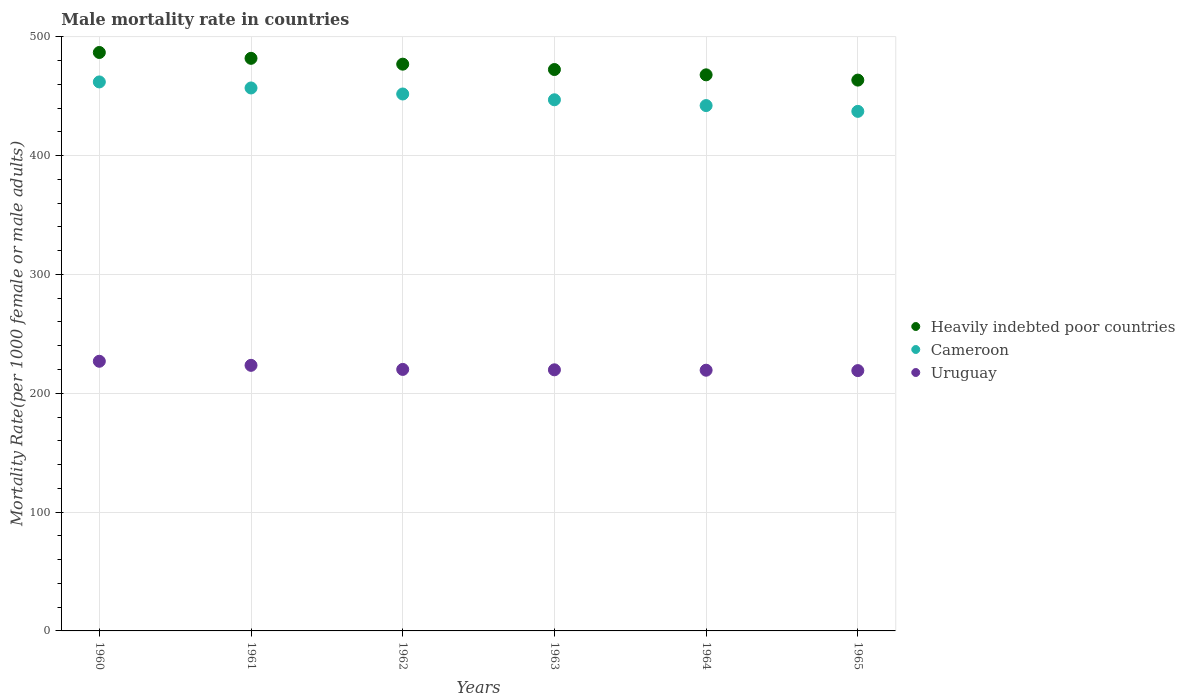How many different coloured dotlines are there?
Provide a short and direct response. 3. What is the male mortality rate in Uruguay in 1965?
Give a very brief answer. 219.07. Across all years, what is the maximum male mortality rate in Uruguay?
Your response must be concise. 226.93. Across all years, what is the minimum male mortality rate in Cameroon?
Your answer should be very brief. 437.24. In which year was the male mortality rate in Cameroon minimum?
Offer a very short reply. 1965. What is the total male mortality rate in Uruguay in the graph?
Offer a terse response. 1328.72. What is the difference between the male mortality rate in Uruguay in 1963 and that in 1965?
Keep it short and to the point. 0.67. What is the difference between the male mortality rate in Heavily indebted poor countries in 1960 and the male mortality rate in Cameroon in 1962?
Keep it short and to the point. 34.94. What is the average male mortality rate in Heavily indebted poor countries per year?
Make the answer very short. 474.93. In the year 1964, what is the difference between the male mortality rate in Uruguay and male mortality rate in Cameroon?
Keep it short and to the point. -222.71. In how many years, is the male mortality rate in Cameroon greater than 320?
Provide a short and direct response. 6. What is the ratio of the male mortality rate in Heavily indebted poor countries in 1961 to that in 1962?
Ensure brevity in your answer.  1.01. Is the difference between the male mortality rate in Uruguay in 1962 and 1963 greater than the difference between the male mortality rate in Cameroon in 1962 and 1963?
Provide a short and direct response. No. What is the difference between the highest and the second highest male mortality rate in Uruguay?
Provide a succinct answer. 3.43. What is the difference between the highest and the lowest male mortality rate in Cameroon?
Your answer should be compact. 24.77. In how many years, is the male mortality rate in Cameroon greater than the average male mortality rate in Cameroon taken over all years?
Provide a succinct answer. 3. Is it the case that in every year, the sum of the male mortality rate in Cameroon and male mortality rate in Heavily indebted poor countries  is greater than the male mortality rate in Uruguay?
Provide a short and direct response. Yes. Does the male mortality rate in Cameroon monotonically increase over the years?
Make the answer very short. No. What is the difference between two consecutive major ticks on the Y-axis?
Provide a short and direct response. 100. Are the values on the major ticks of Y-axis written in scientific E-notation?
Provide a short and direct response. No. Does the graph contain grids?
Provide a succinct answer. Yes. Where does the legend appear in the graph?
Provide a short and direct response. Center right. What is the title of the graph?
Provide a short and direct response. Male mortality rate in countries. Does "Luxembourg" appear as one of the legend labels in the graph?
Offer a very short reply. No. What is the label or title of the Y-axis?
Your response must be concise. Mortality Rate(per 1000 female or male adults). What is the Mortality Rate(per 1000 female or male adults) in Heavily indebted poor countries in 1960?
Provide a succinct answer. 486.79. What is the Mortality Rate(per 1000 female or male adults) of Cameroon in 1960?
Your answer should be very brief. 462.01. What is the Mortality Rate(per 1000 female or male adults) in Uruguay in 1960?
Your answer should be compact. 226.93. What is the Mortality Rate(per 1000 female or male adults) of Heavily indebted poor countries in 1961?
Provide a succinct answer. 481.87. What is the Mortality Rate(per 1000 female or male adults) of Cameroon in 1961?
Your answer should be compact. 456.93. What is the Mortality Rate(per 1000 female or male adults) of Uruguay in 1961?
Keep it short and to the point. 223.5. What is the Mortality Rate(per 1000 female or male adults) in Heavily indebted poor countries in 1962?
Provide a short and direct response. 476.96. What is the Mortality Rate(per 1000 female or male adults) of Cameroon in 1962?
Give a very brief answer. 451.86. What is the Mortality Rate(per 1000 female or male adults) of Uruguay in 1962?
Your answer should be compact. 220.07. What is the Mortality Rate(per 1000 female or male adults) of Heavily indebted poor countries in 1963?
Give a very brief answer. 472.45. What is the Mortality Rate(per 1000 female or male adults) in Cameroon in 1963?
Your response must be concise. 446.98. What is the Mortality Rate(per 1000 female or male adults) of Uruguay in 1963?
Offer a terse response. 219.74. What is the Mortality Rate(per 1000 female or male adults) in Heavily indebted poor countries in 1964?
Offer a very short reply. 467.98. What is the Mortality Rate(per 1000 female or male adults) in Cameroon in 1964?
Your response must be concise. 442.11. What is the Mortality Rate(per 1000 female or male adults) of Uruguay in 1964?
Make the answer very short. 219.4. What is the Mortality Rate(per 1000 female or male adults) in Heavily indebted poor countries in 1965?
Make the answer very short. 463.55. What is the Mortality Rate(per 1000 female or male adults) of Cameroon in 1965?
Your response must be concise. 437.24. What is the Mortality Rate(per 1000 female or male adults) of Uruguay in 1965?
Offer a terse response. 219.07. Across all years, what is the maximum Mortality Rate(per 1000 female or male adults) in Heavily indebted poor countries?
Offer a very short reply. 486.79. Across all years, what is the maximum Mortality Rate(per 1000 female or male adults) in Cameroon?
Your answer should be very brief. 462.01. Across all years, what is the maximum Mortality Rate(per 1000 female or male adults) of Uruguay?
Give a very brief answer. 226.93. Across all years, what is the minimum Mortality Rate(per 1000 female or male adults) of Heavily indebted poor countries?
Offer a terse response. 463.55. Across all years, what is the minimum Mortality Rate(per 1000 female or male adults) in Cameroon?
Your answer should be very brief. 437.24. Across all years, what is the minimum Mortality Rate(per 1000 female or male adults) of Uruguay?
Ensure brevity in your answer.  219.07. What is the total Mortality Rate(per 1000 female or male adults) of Heavily indebted poor countries in the graph?
Offer a very short reply. 2849.6. What is the total Mortality Rate(per 1000 female or male adults) in Cameroon in the graph?
Offer a very short reply. 2697.13. What is the total Mortality Rate(per 1000 female or male adults) of Uruguay in the graph?
Your answer should be very brief. 1328.72. What is the difference between the Mortality Rate(per 1000 female or male adults) of Heavily indebted poor countries in 1960 and that in 1961?
Your answer should be very brief. 4.92. What is the difference between the Mortality Rate(per 1000 female or male adults) of Cameroon in 1960 and that in 1961?
Offer a terse response. 5.08. What is the difference between the Mortality Rate(per 1000 female or male adults) of Uruguay in 1960 and that in 1961?
Make the answer very short. 3.43. What is the difference between the Mortality Rate(per 1000 female or male adults) in Heavily indebted poor countries in 1960 and that in 1962?
Give a very brief answer. 9.83. What is the difference between the Mortality Rate(per 1000 female or male adults) in Cameroon in 1960 and that in 1962?
Offer a terse response. 10.15. What is the difference between the Mortality Rate(per 1000 female or male adults) of Uruguay in 1960 and that in 1962?
Make the answer very short. 6.86. What is the difference between the Mortality Rate(per 1000 female or male adults) of Heavily indebted poor countries in 1960 and that in 1963?
Ensure brevity in your answer.  14.34. What is the difference between the Mortality Rate(per 1000 female or male adults) in Cameroon in 1960 and that in 1963?
Your answer should be compact. 15.02. What is the difference between the Mortality Rate(per 1000 female or male adults) of Uruguay in 1960 and that in 1963?
Offer a terse response. 7.2. What is the difference between the Mortality Rate(per 1000 female or male adults) of Heavily indebted poor countries in 1960 and that in 1964?
Offer a very short reply. 18.81. What is the difference between the Mortality Rate(per 1000 female or male adults) in Cameroon in 1960 and that in 1964?
Make the answer very short. 19.89. What is the difference between the Mortality Rate(per 1000 female or male adults) in Uruguay in 1960 and that in 1964?
Your answer should be very brief. 7.53. What is the difference between the Mortality Rate(per 1000 female or male adults) of Heavily indebted poor countries in 1960 and that in 1965?
Give a very brief answer. 23.24. What is the difference between the Mortality Rate(per 1000 female or male adults) of Cameroon in 1960 and that in 1965?
Give a very brief answer. 24.77. What is the difference between the Mortality Rate(per 1000 female or male adults) in Uruguay in 1960 and that in 1965?
Give a very brief answer. 7.86. What is the difference between the Mortality Rate(per 1000 female or male adults) of Heavily indebted poor countries in 1961 and that in 1962?
Keep it short and to the point. 4.91. What is the difference between the Mortality Rate(per 1000 female or male adults) in Cameroon in 1961 and that in 1962?
Your response must be concise. 5.08. What is the difference between the Mortality Rate(per 1000 female or male adults) in Uruguay in 1961 and that in 1962?
Offer a very short reply. 3.43. What is the difference between the Mortality Rate(per 1000 female or male adults) of Heavily indebted poor countries in 1961 and that in 1963?
Offer a terse response. 9.42. What is the difference between the Mortality Rate(per 1000 female or male adults) of Cameroon in 1961 and that in 1963?
Your answer should be very brief. 9.95. What is the difference between the Mortality Rate(per 1000 female or male adults) in Uruguay in 1961 and that in 1963?
Your answer should be compact. 3.77. What is the difference between the Mortality Rate(per 1000 female or male adults) of Heavily indebted poor countries in 1961 and that in 1964?
Give a very brief answer. 13.89. What is the difference between the Mortality Rate(per 1000 female or male adults) in Cameroon in 1961 and that in 1964?
Your answer should be very brief. 14.82. What is the difference between the Mortality Rate(per 1000 female or male adults) of Uruguay in 1961 and that in 1964?
Offer a terse response. 4.1. What is the difference between the Mortality Rate(per 1000 female or male adults) of Heavily indebted poor countries in 1961 and that in 1965?
Offer a terse response. 18.32. What is the difference between the Mortality Rate(per 1000 female or male adults) of Cameroon in 1961 and that in 1965?
Make the answer very short. 19.69. What is the difference between the Mortality Rate(per 1000 female or male adults) in Uruguay in 1961 and that in 1965?
Give a very brief answer. 4.43. What is the difference between the Mortality Rate(per 1000 female or male adults) of Heavily indebted poor countries in 1962 and that in 1963?
Your response must be concise. 4.51. What is the difference between the Mortality Rate(per 1000 female or male adults) in Cameroon in 1962 and that in 1963?
Offer a terse response. 4.87. What is the difference between the Mortality Rate(per 1000 female or male adults) in Uruguay in 1962 and that in 1963?
Offer a very short reply. 0.33. What is the difference between the Mortality Rate(per 1000 female or male adults) of Heavily indebted poor countries in 1962 and that in 1964?
Offer a very short reply. 8.98. What is the difference between the Mortality Rate(per 1000 female or male adults) in Cameroon in 1962 and that in 1964?
Your answer should be compact. 9.74. What is the difference between the Mortality Rate(per 1000 female or male adults) in Uruguay in 1962 and that in 1964?
Make the answer very short. 0.67. What is the difference between the Mortality Rate(per 1000 female or male adults) of Heavily indebted poor countries in 1962 and that in 1965?
Offer a very short reply. 13.41. What is the difference between the Mortality Rate(per 1000 female or male adults) in Cameroon in 1962 and that in 1965?
Make the answer very short. 14.61. What is the difference between the Mortality Rate(per 1000 female or male adults) in Heavily indebted poor countries in 1963 and that in 1964?
Your answer should be very brief. 4.47. What is the difference between the Mortality Rate(per 1000 female or male adults) in Cameroon in 1963 and that in 1964?
Offer a very short reply. 4.87. What is the difference between the Mortality Rate(per 1000 female or male adults) of Uruguay in 1963 and that in 1964?
Provide a succinct answer. 0.33. What is the difference between the Mortality Rate(per 1000 female or male adults) of Heavily indebted poor countries in 1963 and that in 1965?
Offer a terse response. 8.9. What is the difference between the Mortality Rate(per 1000 female or male adults) of Cameroon in 1963 and that in 1965?
Keep it short and to the point. 9.74. What is the difference between the Mortality Rate(per 1000 female or male adults) of Uruguay in 1963 and that in 1965?
Provide a short and direct response. 0.67. What is the difference between the Mortality Rate(per 1000 female or male adults) of Heavily indebted poor countries in 1964 and that in 1965?
Offer a terse response. 4.43. What is the difference between the Mortality Rate(per 1000 female or male adults) in Cameroon in 1964 and that in 1965?
Provide a succinct answer. 4.87. What is the difference between the Mortality Rate(per 1000 female or male adults) of Uruguay in 1964 and that in 1965?
Offer a very short reply. 0.33. What is the difference between the Mortality Rate(per 1000 female or male adults) in Heavily indebted poor countries in 1960 and the Mortality Rate(per 1000 female or male adults) in Cameroon in 1961?
Your answer should be very brief. 29.86. What is the difference between the Mortality Rate(per 1000 female or male adults) of Heavily indebted poor countries in 1960 and the Mortality Rate(per 1000 female or male adults) of Uruguay in 1961?
Provide a short and direct response. 263.29. What is the difference between the Mortality Rate(per 1000 female or male adults) of Cameroon in 1960 and the Mortality Rate(per 1000 female or male adults) of Uruguay in 1961?
Your response must be concise. 238.5. What is the difference between the Mortality Rate(per 1000 female or male adults) of Heavily indebted poor countries in 1960 and the Mortality Rate(per 1000 female or male adults) of Cameroon in 1962?
Provide a short and direct response. 34.94. What is the difference between the Mortality Rate(per 1000 female or male adults) in Heavily indebted poor countries in 1960 and the Mortality Rate(per 1000 female or male adults) in Uruguay in 1962?
Offer a terse response. 266.72. What is the difference between the Mortality Rate(per 1000 female or male adults) of Cameroon in 1960 and the Mortality Rate(per 1000 female or male adults) of Uruguay in 1962?
Make the answer very short. 241.94. What is the difference between the Mortality Rate(per 1000 female or male adults) of Heavily indebted poor countries in 1960 and the Mortality Rate(per 1000 female or male adults) of Cameroon in 1963?
Provide a succinct answer. 39.81. What is the difference between the Mortality Rate(per 1000 female or male adults) of Heavily indebted poor countries in 1960 and the Mortality Rate(per 1000 female or male adults) of Uruguay in 1963?
Your answer should be very brief. 267.06. What is the difference between the Mortality Rate(per 1000 female or male adults) in Cameroon in 1960 and the Mortality Rate(per 1000 female or male adults) in Uruguay in 1963?
Your answer should be compact. 242.27. What is the difference between the Mortality Rate(per 1000 female or male adults) of Heavily indebted poor countries in 1960 and the Mortality Rate(per 1000 female or male adults) of Cameroon in 1964?
Make the answer very short. 44.68. What is the difference between the Mortality Rate(per 1000 female or male adults) in Heavily indebted poor countries in 1960 and the Mortality Rate(per 1000 female or male adults) in Uruguay in 1964?
Offer a very short reply. 267.39. What is the difference between the Mortality Rate(per 1000 female or male adults) in Cameroon in 1960 and the Mortality Rate(per 1000 female or male adults) in Uruguay in 1964?
Keep it short and to the point. 242.6. What is the difference between the Mortality Rate(per 1000 female or male adults) in Heavily indebted poor countries in 1960 and the Mortality Rate(per 1000 female or male adults) in Cameroon in 1965?
Provide a short and direct response. 49.55. What is the difference between the Mortality Rate(per 1000 female or male adults) in Heavily indebted poor countries in 1960 and the Mortality Rate(per 1000 female or male adults) in Uruguay in 1965?
Ensure brevity in your answer.  267.72. What is the difference between the Mortality Rate(per 1000 female or male adults) of Cameroon in 1960 and the Mortality Rate(per 1000 female or male adults) of Uruguay in 1965?
Your response must be concise. 242.94. What is the difference between the Mortality Rate(per 1000 female or male adults) of Heavily indebted poor countries in 1961 and the Mortality Rate(per 1000 female or male adults) of Cameroon in 1962?
Your answer should be compact. 30.02. What is the difference between the Mortality Rate(per 1000 female or male adults) in Heavily indebted poor countries in 1961 and the Mortality Rate(per 1000 female or male adults) in Uruguay in 1962?
Keep it short and to the point. 261.8. What is the difference between the Mortality Rate(per 1000 female or male adults) in Cameroon in 1961 and the Mortality Rate(per 1000 female or male adults) in Uruguay in 1962?
Offer a terse response. 236.86. What is the difference between the Mortality Rate(per 1000 female or male adults) in Heavily indebted poor countries in 1961 and the Mortality Rate(per 1000 female or male adults) in Cameroon in 1963?
Your answer should be compact. 34.89. What is the difference between the Mortality Rate(per 1000 female or male adults) in Heavily indebted poor countries in 1961 and the Mortality Rate(per 1000 female or male adults) in Uruguay in 1963?
Ensure brevity in your answer.  262.13. What is the difference between the Mortality Rate(per 1000 female or male adults) of Cameroon in 1961 and the Mortality Rate(per 1000 female or male adults) of Uruguay in 1963?
Offer a very short reply. 237.19. What is the difference between the Mortality Rate(per 1000 female or male adults) in Heavily indebted poor countries in 1961 and the Mortality Rate(per 1000 female or male adults) in Cameroon in 1964?
Your answer should be compact. 39.76. What is the difference between the Mortality Rate(per 1000 female or male adults) of Heavily indebted poor countries in 1961 and the Mortality Rate(per 1000 female or male adults) of Uruguay in 1964?
Make the answer very short. 262.47. What is the difference between the Mortality Rate(per 1000 female or male adults) in Cameroon in 1961 and the Mortality Rate(per 1000 female or male adults) in Uruguay in 1964?
Make the answer very short. 237.53. What is the difference between the Mortality Rate(per 1000 female or male adults) in Heavily indebted poor countries in 1961 and the Mortality Rate(per 1000 female or male adults) in Cameroon in 1965?
Offer a terse response. 44.63. What is the difference between the Mortality Rate(per 1000 female or male adults) of Heavily indebted poor countries in 1961 and the Mortality Rate(per 1000 female or male adults) of Uruguay in 1965?
Ensure brevity in your answer.  262.8. What is the difference between the Mortality Rate(per 1000 female or male adults) of Cameroon in 1961 and the Mortality Rate(per 1000 female or male adults) of Uruguay in 1965?
Offer a very short reply. 237.86. What is the difference between the Mortality Rate(per 1000 female or male adults) in Heavily indebted poor countries in 1962 and the Mortality Rate(per 1000 female or male adults) in Cameroon in 1963?
Give a very brief answer. 29.97. What is the difference between the Mortality Rate(per 1000 female or male adults) in Heavily indebted poor countries in 1962 and the Mortality Rate(per 1000 female or male adults) in Uruguay in 1963?
Make the answer very short. 257.22. What is the difference between the Mortality Rate(per 1000 female or male adults) of Cameroon in 1962 and the Mortality Rate(per 1000 female or male adults) of Uruguay in 1963?
Provide a short and direct response. 232.12. What is the difference between the Mortality Rate(per 1000 female or male adults) of Heavily indebted poor countries in 1962 and the Mortality Rate(per 1000 female or male adults) of Cameroon in 1964?
Provide a succinct answer. 34.85. What is the difference between the Mortality Rate(per 1000 female or male adults) in Heavily indebted poor countries in 1962 and the Mortality Rate(per 1000 female or male adults) in Uruguay in 1964?
Provide a short and direct response. 257.55. What is the difference between the Mortality Rate(per 1000 female or male adults) of Cameroon in 1962 and the Mortality Rate(per 1000 female or male adults) of Uruguay in 1964?
Offer a terse response. 232.45. What is the difference between the Mortality Rate(per 1000 female or male adults) of Heavily indebted poor countries in 1962 and the Mortality Rate(per 1000 female or male adults) of Cameroon in 1965?
Your answer should be very brief. 39.72. What is the difference between the Mortality Rate(per 1000 female or male adults) of Heavily indebted poor countries in 1962 and the Mortality Rate(per 1000 female or male adults) of Uruguay in 1965?
Your answer should be very brief. 257.89. What is the difference between the Mortality Rate(per 1000 female or male adults) of Cameroon in 1962 and the Mortality Rate(per 1000 female or male adults) of Uruguay in 1965?
Your response must be concise. 232.78. What is the difference between the Mortality Rate(per 1000 female or male adults) in Heavily indebted poor countries in 1963 and the Mortality Rate(per 1000 female or male adults) in Cameroon in 1964?
Offer a very short reply. 30.34. What is the difference between the Mortality Rate(per 1000 female or male adults) in Heavily indebted poor countries in 1963 and the Mortality Rate(per 1000 female or male adults) in Uruguay in 1964?
Offer a very short reply. 253.05. What is the difference between the Mortality Rate(per 1000 female or male adults) in Cameroon in 1963 and the Mortality Rate(per 1000 female or male adults) in Uruguay in 1964?
Make the answer very short. 227.58. What is the difference between the Mortality Rate(per 1000 female or male adults) in Heavily indebted poor countries in 1963 and the Mortality Rate(per 1000 female or male adults) in Cameroon in 1965?
Make the answer very short. 35.21. What is the difference between the Mortality Rate(per 1000 female or male adults) in Heavily indebted poor countries in 1963 and the Mortality Rate(per 1000 female or male adults) in Uruguay in 1965?
Provide a short and direct response. 253.38. What is the difference between the Mortality Rate(per 1000 female or male adults) of Cameroon in 1963 and the Mortality Rate(per 1000 female or male adults) of Uruguay in 1965?
Make the answer very short. 227.91. What is the difference between the Mortality Rate(per 1000 female or male adults) in Heavily indebted poor countries in 1964 and the Mortality Rate(per 1000 female or male adults) in Cameroon in 1965?
Provide a succinct answer. 30.74. What is the difference between the Mortality Rate(per 1000 female or male adults) in Heavily indebted poor countries in 1964 and the Mortality Rate(per 1000 female or male adults) in Uruguay in 1965?
Make the answer very short. 248.91. What is the difference between the Mortality Rate(per 1000 female or male adults) of Cameroon in 1964 and the Mortality Rate(per 1000 female or male adults) of Uruguay in 1965?
Ensure brevity in your answer.  223.04. What is the average Mortality Rate(per 1000 female or male adults) of Heavily indebted poor countries per year?
Offer a very short reply. 474.93. What is the average Mortality Rate(per 1000 female or male adults) of Cameroon per year?
Ensure brevity in your answer.  449.52. What is the average Mortality Rate(per 1000 female or male adults) in Uruguay per year?
Your response must be concise. 221.45. In the year 1960, what is the difference between the Mortality Rate(per 1000 female or male adults) of Heavily indebted poor countries and Mortality Rate(per 1000 female or male adults) of Cameroon?
Keep it short and to the point. 24.79. In the year 1960, what is the difference between the Mortality Rate(per 1000 female or male adults) in Heavily indebted poor countries and Mortality Rate(per 1000 female or male adults) in Uruguay?
Give a very brief answer. 259.86. In the year 1960, what is the difference between the Mortality Rate(per 1000 female or male adults) in Cameroon and Mortality Rate(per 1000 female or male adults) in Uruguay?
Offer a terse response. 235.07. In the year 1961, what is the difference between the Mortality Rate(per 1000 female or male adults) of Heavily indebted poor countries and Mortality Rate(per 1000 female or male adults) of Cameroon?
Your answer should be compact. 24.94. In the year 1961, what is the difference between the Mortality Rate(per 1000 female or male adults) of Heavily indebted poor countries and Mortality Rate(per 1000 female or male adults) of Uruguay?
Make the answer very short. 258.37. In the year 1961, what is the difference between the Mortality Rate(per 1000 female or male adults) in Cameroon and Mortality Rate(per 1000 female or male adults) in Uruguay?
Give a very brief answer. 233.43. In the year 1962, what is the difference between the Mortality Rate(per 1000 female or male adults) of Heavily indebted poor countries and Mortality Rate(per 1000 female or male adults) of Cameroon?
Your answer should be very brief. 25.1. In the year 1962, what is the difference between the Mortality Rate(per 1000 female or male adults) of Heavily indebted poor countries and Mortality Rate(per 1000 female or male adults) of Uruguay?
Offer a very short reply. 256.89. In the year 1962, what is the difference between the Mortality Rate(per 1000 female or male adults) in Cameroon and Mortality Rate(per 1000 female or male adults) in Uruguay?
Give a very brief answer. 231.78. In the year 1963, what is the difference between the Mortality Rate(per 1000 female or male adults) of Heavily indebted poor countries and Mortality Rate(per 1000 female or male adults) of Cameroon?
Make the answer very short. 25.47. In the year 1963, what is the difference between the Mortality Rate(per 1000 female or male adults) of Heavily indebted poor countries and Mortality Rate(per 1000 female or male adults) of Uruguay?
Give a very brief answer. 252.71. In the year 1963, what is the difference between the Mortality Rate(per 1000 female or male adults) of Cameroon and Mortality Rate(per 1000 female or male adults) of Uruguay?
Keep it short and to the point. 227.25. In the year 1964, what is the difference between the Mortality Rate(per 1000 female or male adults) of Heavily indebted poor countries and Mortality Rate(per 1000 female or male adults) of Cameroon?
Offer a very short reply. 25.87. In the year 1964, what is the difference between the Mortality Rate(per 1000 female or male adults) in Heavily indebted poor countries and Mortality Rate(per 1000 female or male adults) in Uruguay?
Offer a terse response. 248.58. In the year 1964, what is the difference between the Mortality Rate(per 1000 female or male adults) of Cameroon and Mortality Rate(per 1000 female or male adults) of Uruguay?
Offer a terse response. 222.71. In the year 1965, what is the difference between the Mortality Rate(per 1000 female or male adults) in Heavily indebted poor countries and Mortality Rate(per 1000 female or male adults) in Cameroon?
Make the answer very short. 26.31. In the year 1965, what is the difference between the Mortality Rate(per 1000 female or male adults) of Heavily indebted poor countries and Mortality Rate(per 1000 female or male adults) of Uruguay?
Offer a very short reply. 244.48. In the year 1965, what is the difference between the Mortality Rate(per 1000 female or male adults) in Cameroon and Mortality Rate(per 1000 female or male adults) in Uruguay?
Your answer should be very brief. 218.17. What is the ratio of the Mortality Rate(per 1000 female or male adults) of Heavily indebted poor countries in 1960 to that in 1961?
Offer a terse response. 1.01. What is the ratio of the Mortality Rate(per 1000 female or male adults) of Cameroon in 1960 to that in 1961?
Your answer should be very brief. 1.01. What is the ratio of the Mortality Rate(per 1000 female or male adults) in Uruguay in 1960 to that in 1961?
Keep it short and to the point. 1.02. What is the ratio of the Mortality Rate(per 1000 female or male adults) of Heavily indebted poor countries in 1960 to that in 1962?
Ensure brevity in your answer.  1.02. What is the ratio of the Mortality Rate(per 1000 female or male adults) in Cameroon in 1960 to that in 1962?
Give a very brief answer. 1.02. What is the ratio of the Mortality Rate(per 1000 female or male adults) in Uruguay in 1960 to that in 1962?
Your answer should be very brief. 1.03. What is the ratio of the Mortality Rate(per 1000 female or male adults) of Heavily indebted poor countries in 1960 to that in 1963?
Ensure brevity in your answer.  1.03. What is the ratio of the Mortality Rate(per 1000 female or male adults) in Cameroon in 1960 to that in 1963?
Provide a succinct answer. 1.03. What is the ratio of the Mortality Rate(per 1000 female or male adults) of Uruguay in 1960 to that in 1963?
Provide a short and direct response. 1.03. What is the ratio of the Mortality Rate(per 1000 female or male adults) of Heavily indebted poor countries in 1960 to that in 1964?
Provide a short and direct response. 1.04. What is the ratio of the Mortality Rate(per 1000 female or male adults) in Cameroon in 1960 to that in 1964?
Offer a terse response. 1.04. What is the ratio of the Mortality Rate(per 1000 female or male adults) of Uruguay in 1960 to that in 1964?
Your answer should be very brief. 1.03. What is the ratio of the Mortality Rate(per 1000 female or male adults) of Heavily indebted poor countries in 1960 to that in 1965?
Your response must be concise. 1.05. What is the ratio of the Mortality Rate(per 1000 female or male adults) of Cameroon in 1960 to that in 1965?
Your answer should be compact. 1.06. What is the ratio of the Mortality Rate(per 1000 female or male adults) of Uruguay in 1960 to that in 1965?
Make the answer very short. 1.04. What is the ratio of the Mortality Rate(per 1000 female or male adults) in Heavily indebted poor countries in 1961 to that in 1962?
Ensure brevity in your answer.  1.01. What is the ratio of the Mortality Rate(per 1000 female or male adults) of Cameroon in 1961 to that in 1962?
Ensure brevity in your answer.  1.01. What is the ratio of the Mortality Rate(per 1000 female or male adults) in Uruguay in 1961 to that in 1962?
Your answer should be very brief. 1.02. What is the ratio of the Mortality Rate(per 1000 female or male adults) in Heavily indebted poor countries in 1961 to that in 1963?
Your answer should be compact. 1.02. What is the ratio of the Mortality Rate(per 1000 female or male adults) in Cameroon in 1961 to that in 1963?
Your response must be concise. 1.02. What is the ratio of the Mortality Rate(per 1000 female or male adults) in Uruguay in 1961 to that in 1963?
Make the answer very short. 1.02. What is the ratio of the Mortality Rate(per 1000 female or male adults) of Heavily indebted poor countries in 1961 to that in 1964?
Make the answer very short. 1.03. What is the ratio of the Mortality Rate(per 1000 female or male adults) in Cameroon in 1961 to that in 1964?
Ensure brevity in your answer.  1.03. What is the ratio of the Mortality Rate(per 1000 female or male adults) of Uruguay in 1961 to that in 1964?
Provide a short and direct response. 1.02. What is the ratio of the Mortality Rate(per 1000 female or male adults) of Heavily indebted poor countries in 1961 to that in 1965?
Offer a very short reply. 1.04. What is the ratio of the Mortality Rate(per 1000 female or male adults) in Cameroon in 1961 to that in 1965?
Offer a very short reply. 1.04. What is the ratio of the Mortality Rate(per 1000 female or male adults) in Uruguay in 1961 to that in 1965?
Offer a terse response. 1.02. What is the ratio of the Mortality Rate(per 1000 female or male adults) of Heavily indebted poor countries in 1962 to that in 1963?
Your response must be concise. 1.01. What is the ratio of the Mortality Rate(per 1000 female or male adults) in Cameroon in 1962 to that in 1963?
Offer a terse response. 1.01. What is the ratio of the Mortality Rate(per 1000 female or male adults) of Heavily indebted poor countries in 1962 to that in 1964?
Keep it short and to the point. 1.02. What is the ratio of the Mortality Rate(per 1000 female or male adults) of Cameroon in 1962 to that in 1964?
Ensure brevity in your answer.  1.02. What is the ratio of the Mortality Rate(per 1000 female or male adults) in Heavily indebted poor countries in 1962 to that in 1965?
Your answer should be compact. 1.03. What is the ratio of the Mortality Rate(per 1000 female or male adults) of Cameroon in 1962 to that in 1965?
Provide a short and direct response. 1.03. What is the ratio of the Mortality Rate(per 1000 female or male adults) of Heavily indebted poor countries in 1963 to that in 1964?
Provide a short and direct response. 1.01. What is the ratio of the Mortality Rate(per 1000 female or male adults) in Cameroon in 1963 to that in 1964?
Ensure brevity in your answer.  1.01. What is the ratio of the Mortality Rate(per 1000 female or male adults) of Heavily indebted poor countries in 1963 to that in 1965?
Offer a very short reply. 1.02. What is the ratio of the Mortality Rate(per 1000 female or male adults) in Cameroon in 1963 to that in 1965?
Ensure brevity in your answer.  1.02. What is the ratio of the Mortality Rate(per 1000 female or male adults) in Uruguay in 1963 to that in 1965?
Your answer should be very brief. 1. What is the ratio of the Mortality Rate(per 1000 female or male adults) of Heavily indebted poor countries in 1964 to that in 1965?
Ensure brevity in your answer.  1.01. What is the ratio of the Mortality Rate(per 1000 female or male adults) in Cameroon in 1964 to that in 1965?
Ensure brevity in your answer.  1.01. What is the difference between the highest and the second highest Mortality Rate(per 1000 female or male adults) of Heavily indebted poor countries?
Offer a terse response. 4.92. What is the difference between the highest and the second highest Mortality Rate(per 1000 female or male adults) of Cameroon?
Provide a short and direct response. 5.08. What is the difference between the highest and the second highest Mortality Rate(per 1000 female or male adults) of Uruguay?
Offer a very short reply. 3.43. What is the difference between the highest and the lowest Mortality Rate(per 1000 female or male adults) of Heavily indebted poor countries?
Offer a very short reply. 23.24. What is the difference between the highest and the lowest Mortality Rate(per 1000 female or male adults) of Cameroon?
Offer a very short reply. 24.77. What is the difference between the highest and the lowest Mortality Rate(per 1000 female or male adults) in Uruguay?
Give a very brief answer. 7.86. 